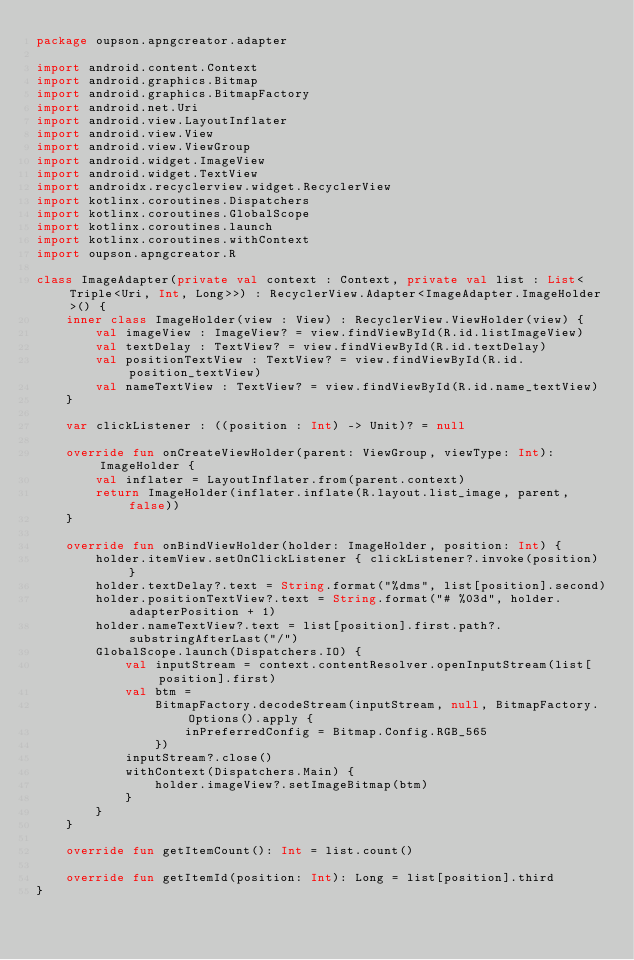<code> <loc_0><loc_0><loc_500><loc_500><_Kotlin_>package oupson.apngcreator.adapter

import android.content.Context
import android.graphics.Bitmap
import android.graphics.BitmapFactory
import android.net.Uri
import android.view.LayoutInflater
import android.view.View
import android.view.ViewGroup
import android.widget.ImageView
import android.widget.TextView
import androidx.recyclerview.widget.RecyclerView
import kotlinx.coroutines.Dispatchers
import kotlinx.coroutines.GlobalScope
import kotlinx.coroutines.launch
import kotlinx.coroutines.withContext
import oupson.apngcreator.R

class ImageAdapter(private val context : Context, private val list : List<Triple<Uri, Int, Long>>) : RecyclerView.Adapter<ImageAdapter.ImageHolder>() {
    inner class ImageHolder(view : View) : RecyclerView.ViewHolder(view) {
        val imageView : ImageView? = view.findViewById(R.id.listImageView)
        val textDelay : TextView? = view.findViewById(R.id.textDelay)
        val positionTextView : TextView? = view.findViewById(R.id.position_textView)
        val nameTextView : TextView? = view.findViewById(R.id.name_textView)
    }

    var clickListener : ((position : Int) -> Unit)? = null

    override fun onCreateViewHolder(parent: ViewGroup, viewType: Int): ImageHolder {
        val inflater = LayoutInflater.from(parent.context)
        return ImageHolder(inflater.inflate(R.layout.list_image, parent, false))
    }

    override fun onBindViewHolder(holder: ImageHolder, position: Int) {
        holder.itemView.setOnClickListener { clickListener?.invoke(position) }
        holder.textDelay?.text = String.format("%dms", list[position].second)
        holder.positionTextView?.text = String.format("# %03d", holder.adapterPosition + 1)
        holder.nameTextView?.text = list[position].first.path?.substringAfterLast("/")
        GlobalScope.launch(Dispatchers.IO) {
            val inputStream = context.contentResolver.openInputStream(list[position].first)
            val btm =
                BitmapFactory.decodeStream(inputStream, null, BitmapFactory.Options().apply {
                    inPreferredConfig = Bitmap.Config.RGB_565
                })
            inputStream?.close()
            withContext(Dispatchers.Main) {
                holder.imageView?.setImageBitmap(btm)
            }
        }
    }

    override fun getItemCount(): Int = list.count()

    override fun getItemId(position: Int): Long = list[position].third
}</code> 